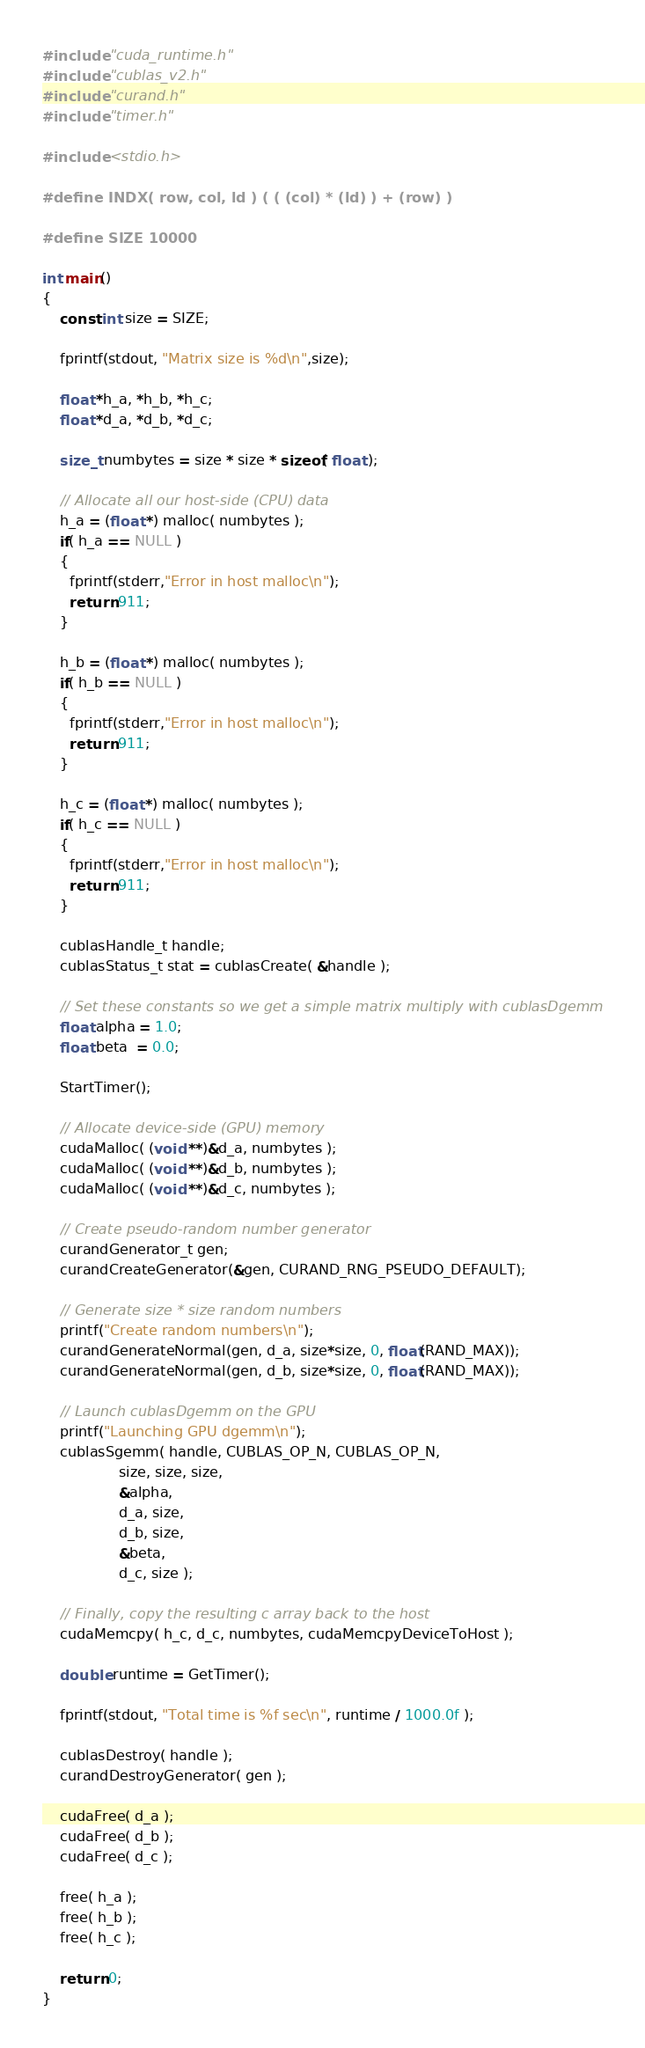Convert code to text. <code><loc_0><loc_0><loc_500><loc_500><_Cuda_>#include "cuda_runtime.h"
#include "cublas_v2.h"
#include "curand.h"
#include "timer.h"

#include <stdio.h>

#define INDX( row, col, ld ) ( ( (col) * (ld) ) + (row) )

#define SIZE 10000

int main()
{
    const int size = SIZE;

    fprintf(stdout, "Matrix size is %d\n",size);

    float *h_a, *h_b, *h_c;
    float *d_a, *d_b, *d_c;
 
    size_t numbytes = size * size * sizeof( float );

    // Allocate all our host-side (CPU) data
    h_a = (float *) malloc( numbytes );
    if( h_a == NULL )
    {
      fprintf(stderr,"Error in host malloc\n");
      return 911;
    }

    h_b = (float *) malloc( numbytes );
    if( h_b == NULL )
    {
      fprintf(stderr,"Error in host malloc\n");
      return 911;
    }

    h_c = (float *) malloc( numbytes );
    if( h_c == NULL )
    {
      fprintf(stderr,"Error in host malloc\n");
      return 911;
    }

    cublasHandle_t handle;
    cublasStatus_t stat = cublasCreate( &handle );

    // Set these constants so we get a simple matrix multiply with cublasDgemm
    float alpha = 1.0;
    float beta  = 0.0;
  
    StartTimer();

    // Allocate device-side (GPU) memory
    cudaMalloc( (void **)&d_a, numbytes );
    cudaMalloc( (void **)&d_b, numbytes );
    cudaMalloc( (void **)&d_c, numbytes );

    // Create pseudo-random number generator
    curandGenerator_t gen;
    curandCreateGenerator(&gen, CURAND_RNG_PSEUDO_DEFAULT);

    // Generate size * size random numbers
    printf("Create random numbers\n");
    curandGenerateNormal(gen, d_a, size*size, 0, float(RAND_MAX));
    curandGenerateNormal(gen, d_b, size*size, 0, float(RAND_MAX));
  
    // Launch cublasDgemm on the GPU
    printf("Launching GPU dgemm\n");
    cublasSgemm( handle, CUBLAS_OP_N, CUBLAS_OP_N,
                 size, size, size,
                 &alpha, 
                 d_a, size,
                 d_b, size,
                 &beta,
                 d_c, size );

    // Finally, copy the resulting c array back to the host  
    cudaMemcpy( h_c, d_c, numbytes, cudaMemcpyDeviceToHost );

    double runtime = GetTimer();

    fprintf(stdout, "Total time is %f sec\n", runtime / 1000.0f );

    cublasDestroy( handle );
    curandDestroyGenerator( gen );

    cudaFree( d_a );
    cudaFree( d_b );
    cudaFree( d_c );

    free( h_a );
    free( h_b );
    free( h_c );

    return 0;
}
</code> 